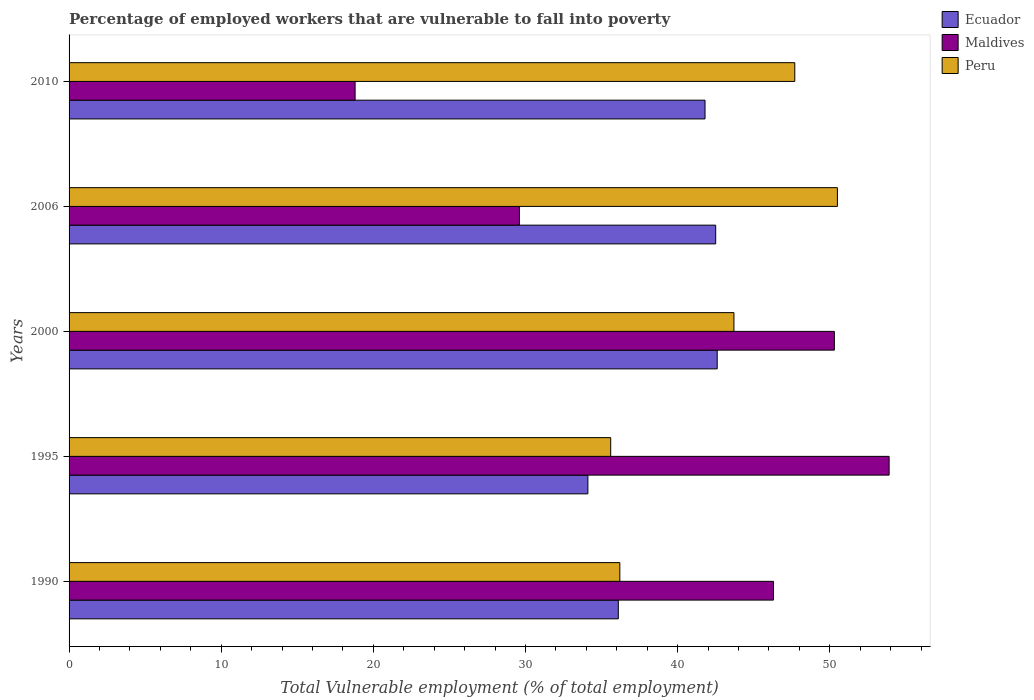How many different coloured bars are there?
Keep it short and to the point. 3. How many groups of bars are there?
Your answer should be compact. 5. Are the number of bars per tick equal to the number of legend labels?
Give a very brief answer. Yes. How many bars are there on the 5th tick from the top?
Keep it short and to the point. 3. What is the label of the 5th group of bars from the top?
Provide a short and direct response. 1990. In how many cases, is the number of bars for a given year not equal to the number of legend labels?
Provide a succinct answer. 0. What is the percentage of employed workers who are vulnerable to fall into poverty in Ecuador in 1995?
Make the answer very short. 34.1. Across all years, what is the maximum percentage of employed workers who are vulnerable to fall into poverty in Ecuador?
Make the answer very short. 42.6. Across all years, what is the minimum percentage of employed workers who are vulnerable to fall into poverty in Peru?
Your answer should be compact. 35.6. In which year was the percentage of employed workers who are vulnerable to fall into poverty in Ecuador maximum?
Provide a short and direct response. 2000. What is the total percentage of employed workers who are vulnerable to fall into poverty in Maldives in the graph?
Give a very brief answer. 198.9. What is the difference between the percentage of employed workers who are vulnerable to fall into poverty in Maldives in 2000 and that in 2010?
Ensure brevity in your answer.  31.5. What is the difference between the percentage of employed workers who are vulnerable to fall into poverty in Ecuador in 2000 and the percentage of employed workers who are vulnerable to fall into poverty in Maldives in 1995?
Provide a short and direct response. -11.3. What is the average percentage of employed workers who are vulnerable to fall into poverty in Peru per year?
Offer a terse response. 42.74. In the year 2006, what is the difference between the percentage of employed workers who are vulnerable to fall into poverty in Maldives and percentage of employed workers who are vulnerable to fall into poverty in Ecuador?
Your answer should be very brief. -12.9. What is the ratio of the percentage of employed workers who are vulnerable to fall into poverty in Maldives in 2000 to that in 2010?
Make the answer very short. 2.68. Is the percentage of employed workers who are vulnerable to fall into poverty in Peru in 1995 less than that in 2010?
Make the answer very short. Yes. What is the difference between the highest and the second highest percentage of employed workers who are vulnerable to fall into poverty in Maldives?
Your response must be concise. 3.6. What is the difference between the highest and the lowest percentage of employed workers who are vulnerable to fall into poverty in Peru?
Provide a short and direct response. 14.9. In how many years, is the percentage of employed workers who are vulnerable to fall into poverty in Ecuador greater than the average percentage of employed workers who are vulnerable to fall into poverty in Ecuador taken over all years?
Your response must be concise. 3. Is the sum of the percentage of employed workers who are vulnerable to fall into poverty in Ecuador in 2006 and 2010 greater than the maximum percentage of employed workers who are vulnerable to fall into poverty in Peru across all years?
Offer a very short reply. Yes. What does the 3rd bar from the top in 2006 represents?
Give a very brief answer. Ecuador. What does the 3rd bar from the bottom in 1995 represents?
Keep it short and to the point. Peru. How many years are there in the graph?
Your answer should be compact. 5. What is the difference between two consecutive major ticks on the X-axis?
Your answer should be compact. 10. Are the values on the major ticks of X-axis written in scientific E-notation?
Give a very brief answer. No. Does the graph contain any zero values?
Your answer should be compact. No. Does the graph contain grids?
Provide a short and direct response. No. Where does the legend appear in the graph?
Your answer should be very brief. Top right. How many legend labels are there?
Provide a succinct answer. 3. What is the title of the graph?
Your answer should be very brief. Percentage of employed workers that are vulnerable to fall into poverty. Does "Europe(developing only)" appear as one of the legend labels in the graph?
Ensure brevity in your answer.  No. What is the label or title of the X-axis?
Ensure brevity in your answer.  Total Vulnerable employment (% of total employment). What is the Total Vulnerable employment (% of total employment) of Ecuador in 1990?
Give a very brief answer. 36.1. What is the Total Vulnerable employment (% of total employment) of Maldives in 1990?
Your answer should be compact. 46.3. What is the Total Vulnerable employment (% of total employment) of Peru in 1990?
Provide a short and direct response. 36.2. What is the Total Vulnerable employment (% of total employment) of Ecuador in 1995?
Offer a terse response. 34.1. What is the Total Vulnerable employment (% of total employment) in Maldives in 1995?
Ensure brevity in your answer.  53.9. What is the Total Vulnerable employment (% of total employment) of Peru in 1995?
Ensure brevity in your answer.  35.6. What is the Total Vulnerable employment (% of total employment) in Ecuador in 2000?
Ensure brevity in your answer.  42.6. What is the Total Vulnerable employment (% of total employment) in Maldives in 2000?
Ensure brevity in your answer.  50.3. What is the Total Vulnerable employment (% of total employment) of Peru in 2000?
Offer a very short reply. 43.7. What is the Total Vulnerable employment (% of total employment) in Ecuador in 2006?
Keep it short and to the point. 42.5. What is the Total Vulnerable employment (% of total employment) of Maldives in 2006?
Your response must be concise. 29.6. What is the Total Vulnerable employment (% of total employment) of Peru in 2006?
Ensure brevity in your answer.  50.5. What is the Total Vulnerable employment (% of total employment) of Ecuador in 2010?
Your answer should be compact. 41.8. What is the Total Vulnerable employment (% of total employment) in Maldives in 2010?
Give a very brief answer. 18.8. What is the Total Vulnerable employment (% of total employment) of Peru in 2010?
Make the answer very short. 47.7. Across all years, what is the maximum Total Vulnerable employment (% of total employment) of Ecuador?
Your answer should be very brief. 42.6. Across all years, what is the maximum Total Vulnerable employment (% of total employment) of Maldives?
Your answer should be very brief. 53.9. Across all years, what is the maximum Total Vulnerable employment (% of total employment) of Peru?
Offer a terse response. 50.5. Across all years, what is the minimum Total Vulnerable employment (% of total employment) of Ecuador?
Your answer should be very brief. 34.1. Across all years, what is the minimum Total Vulnerable employment (% of total employment) of Maldives?
Offer a very short reply. 18.8. Across all years, what is the minimum Total Vulnerable employment (% of total employment) in Peru?
Offer a terse response. 35.6. What is the total Total Vulnerable employment (% of total employment) of Ecuador in the graph?
Offer a very short reply. 197.1. What is the total Total Vulnerable employment (% of total employment) in Maldives in the graph?
Provide a short and direct response. 198.9. What is the total Total Vulnerable employment (% of total employment) in Peru in the graph?
Offer a terse response. 213.7. What is the difference between the Total Vulnerable employment (% of total employment) in Ecuador in 1990 and that in 1995?
Your answer should be very brief. 2. What is the difference between the Total Vulnerable employment (% of total employment) of Maldives in 1990 and that in 1995?
Your response must be concise. -7.6. What is the difference between the Total Vulnerable employment (% of total employment) of Ecuador in 1990 and that in 2000?
Your response must be concise. -6.5. What is the difference between the Total Vulnerable employment (% of total employment) of Maldives in 1990 and that in 2000?
Your answer should be compact. -4. What is the difference between the Total Vulnerable employment (% of total employment) of Peru in 1990 and that in 2006?
Your answer should be compact. -14.3. What is the difference between the Total Vulnerable employment (% of total employment) in Maldives in 1990 and that in 2010?
Provide a succinct answer. 27.5. What is the difference between the Total Vulnerable employment (% of total employment) of Ecuador in 1995 and that in 2000?
Offer a very short reply. -8.5. What is the difference between the Total Vulnerable employment (% of total employment) of Maldives in 1995 and that in 2000?
Make the answer very short. 3.6. What is the difference between the Total Vulnerable employment (% of total employment) in Maldives in 1995 and that in 2006?
Your answer should be compact. 24.3. What is the difference between the Total Vulnerable employment (% of total employment) of Peru in 1995 and that in 2006?
Give a very brief answer. -14.9. What is the difference between the Total Vulnerable employment (% of total employment) of Ecuador in 1995 and that in 2010?
Your answer should be compact. -7.7. What is the difference between the Total Vulnerable employment (% of total employment) in Maldives in 1995 and that in 2010?
Your answer should be very brief. 35.1. What is the difference between the Total Vulnerable employment (% of total employment) of Maldives in 2000 and that in 2006?
Provide a succinct answer. 20.7. What is the difference between the Total Vulnerable employment (% of total employment) in Peru in 2000 and that in 2006?
Provide a short and direct response. -6.8. What is the difference between the Total Vulnerable employment (% of total employment) in Maldives in 2000 and that in 2010?
Your answer should be very brief. 31.5. What is the difference between the Total Vulnerable employment (% of total employment) in Maldives in 2006 and that in 2010?
Your response must be concise. 10.8. What is the difference between the Total Vulnerable employment (% of total employment) in Ecuador in 1990 and the Total Vulnerable employment (% of total employment) in Maldives in 1995?
Offer a terse response. -17.8. What is the difference between the Total Vulnerable employment (% of total employment) in Ecuador in 1990 and the Total Vulnerable employment (% of total employment) in Peru in 1995?
Offer a terse response. 0.5. What is the difference between the Total Vulnerable employment (% of total employment) in Maldives in 1990 and the Total Vulnerable employment (% of total employment) in Peru in 1995?
Ensure brevity in your answer.  10.7. What is the difference between the Total Vulnerable employment (% of total employment) of Ecuador in 1990 and the Total Vulnerable employment (% of total employment) of Maldives in 2000?
Offer a terse response. -14.2. What is the difference between the Total Vulnerable employment (% of total employment) of Maldives in 1990 and the Total Vulnerable employment (% of total employment) of Peru in 2000?
Ensure brevity in your answer.  2.6. What is the difference between the Total Vulnerable employment (% of total employment) of Ecuador in 1990 and the Total Vulnerable employment (% of total employment) of Peru in 2006?
Give a very brief answer. -14.4. What is the difference between the Total Vulnerable employment (% of total employment) in Maldives in 1990 and the Total Vulnerable employment (% of total employment) in Peru in 2006?
Your response must be concise. -4.2. What is the difference between the Total Vulnerable employment (% of total employment) in Ecuador in 1990 and the Total Vulnerable employment (% of total employment) in Maldives in 2010?
Keep it short and to the point. 17.3. What is the difference between the Total Vulnerable employment (% of total employment) in Ecuador in 1990 and the Total Vulnerable employment (% of total employment) in Peru in 2010?
Give a very brief answer. -11.6. What is the difference between the Total Vulnerable employment (% of total employment) in Ecuador in 1995 and the Total Vulnerable employment (% of total employment) in Maldives in 2000?
Your answer should be very brief. -16.2. What is the difference between the Total Vulnerable employment (% of total employment) in Ecuador in 1995 and the Total Vulnerable employment (% of total employment) in Peru in 2000?
Your answer should be compact. -9.6. What is the difference between the Total Vulnerable employment (% of total employment) in Maldives in 1995 and the Total Vulnerable employment (% of total employment) in Peru in 2000?
Your answer should be compact. 10.2. What is the difference between the Total Vulnerable employment (% of total employment) of Ecuador in 1995 and the Total Vulnerable employment (% of total employment) of Maldives in 2006?
Provide a short and direct response. 4.5. What is the difference between the Total Vulnerable employment (% of total employment) of Ecuador in 1995 and the Total Vulnerable employment (% of total employment) of Peru in 2006?
Make the answer very short. -16.4. What is the difference between the Total Vulnerable employment (% of total employment) in Maldives in 1995 and the Total Vulnerable employment (% of total employment) in Peru in 2006?
Your answer should be compact. 3.4. What is the difference between the Total Vulnerable employment (% of total employment) of Ecuador in 2000 and the Total Vulnerable employment (% of total employment) of Maldives in 2006?
Your answer should be very brief. 13. What is the difference between the Total Vulnerable employment (% of total employment) of Ecuador in 2000 and the Total Vulnerable employment (% of total employment) of Peru in 2006?
Offer a terse response. -7.9. What is the difference between the Total Vulnerable employment (% of total employment) in Maldives in 2000 and the Total Vulnerable employment (% of total employment) in Peru in 2006?
Make the answer very short. -0.2. What is the difference between the Total Vulnerable employment (% of total employment) of Ecuador in 2000 and the Total Vulnerable employment (% of total employment) of Maldives in 2010?
Make the answer very short. 23.8. What is the difference between the Total Vulnerable employment (% of total employment) of Ecuador in 2006 and the Total Vulnerable employment (% of total employment) of Maldives in 2010?
Your answer should be very brief. 23.7. What is the difference between the Total Vulnerable employment (% of total employment) of Ecuador in 2006 and the Total Vulnerable employment (% of total employment) of Peru in 2010?
Offer a very short reply. -5.2. What is the difference between the Total Vulnerable employment (% of total employment) of Maldives in 2006 and the Total Vulnerable employment (% of total employment) of Peru in 2010?
Give a very brief answer. -18.1. What is the average Total Vulnerable employment (% of total employment) in Ecuador per year?
Your answer should be very brief. 39.42. What is the average Total Vulnerable employment (% of total employment) in Maldives per year?
Your answer should be very brief. 39.78. What is the average Total Vulnerable employment (% of total employment) in Peru per year?
Provide a succinct answer. 42.74. In the year 1990, what is the difference between the Total Vulnerable employment (% of total employment) in Ecuador and Total Vulnerable employment (% of total employment) in Peru?
Provide a short and direct response. -0.1. In the year 1990, what is the difference between the Total Vulnerable employment (% of total employment) of Maldives and Total Vulnerable employment (% of total employment) of Peru?
Your response must be concise. 10.1. In the year 1995, what is the difference between the Total Vulnerable employment (% of total employment) of Ecuador and Total Vulnerable employment (% of total employment) of Maldives?
Give a very brief answer. -19.8. In the year 1995, what is the difference between the Total Vulnerable employment (% of total employment) in Ecuador and Total Vulnerable employment (% of total employment) in Peru?
Provide a succinct answer. -1.5. In the year 1995, what is the difference between the Total Vulnerable employment (% of total employment) in Maldives and Total Vulnerable employment (% of total employment) in Peru?
Your answer should be compact. 18.3. In the year 2000, what is the difference between the Total Vulnerable employment (% of total employment) of Ecuador and Total Vulnerable employment (% of total employment) of Peru?
Keep it short and to the point. -1.1. In the year 2000, what is the difference between the Total Vulnerable employment (% of total employment) in Maldives and Total Vulnerable employment (% of total employment) in Peru?
Offer a terse response. 6.6. In the year 2006, what is the difference between the Total Vulnerable employment (% of total employment) in Ecuador and Total Vulnerable employment (% of total employment) in Maldives?
Offer a very short reply. 12.9. In the year 2006, what is the difference between the Total Vulnerable employment (% of total employment) in Maldives and Total Vulnerable employment (% of total employment) in Peru?
Your answer should be very brief. -20.9. In the year 2010, what is the difference between the Total Vulnerable employment (% of total employment) of Ecuador and Total Vulnerable employment (% of total employment) of Maldives?
Your answer should be very brief. 23. In the year 2010, what is the difference between the Total Vulnerable employment (% of total employment) in Maldives and Total Vulnerable employment (% of total employment) in Peru?
Give a very brief answer. -28.9. What is the ratio of the Total Vulnerable employment (% of total employment) in Ecuador in 1990 to that in 1995?
Your answer should be very brief. 1.06. What is the ratio of the Total Vulnerable employment (% of total employment) in Maldives in 1990 to that in 1995?
Ensure brevity in your answer.  0.86. What is the ratio of the Total Vulnerable employment (% of total employment) of Peru in 1990 to that in 1995?
Make the answer very short. 1.02. What is the ratio of the Total Vulnerable employment (% of total employment) in Ecuador in 1990 to that in 2000?
Offer a very short reply. 0.85. What is the ratio of the Total Vulnerable employment (% of total employment) of Maldives in 1990 to that in 2000?
Your answer should be compact. 0.92. What is the ratio of the Total Vulnerable employment (% of total employment) of Peru in 1990 to that in 2000?
Give a very brief answer. 0.83. What is the ratio of the Total Vulnerable employment (% of total employment) of Ecuador in 1990 to that in 2006?
Provide a succinct answer. 0.85. What is the ratio of the Total Vulnerable employment (% of total employment) of Maldives in 1990 to that in 2006?
Offer a terse response. 1.56. What is the ratio of the Total Vulnerable employment (% of total employment) of Peru in 1990 to that in 2006?
Provide a short and direct response. 0.72. What is the ratio of the Total Vulnerable employment (% of total employment) of Ecuador in 1990 to that in 2010?
Provide a succinct answer. 0.86. What is the ratio of the Total Vulnerable employment (% of total employment) of Maldives in 1990 to that in 2010?
Make the answer very short. 2.46. What is the ratio of the Total Vulnerable employment (% of total employment) in Peru in 1990 to that in 2010?
Keep it short and to the point. 0.76. What is the ratio of the Total Vulnerable employment (% of total employment) in Ecuador in 1995 to that in 2000?
Offer a terse response. 0.8. What is the ratio of the Total Vulnerable employment (% of total employment) in Maldives in 1995 to that in 2000?
Provide a succinct answer. 1.07. What is the ratio of the Total Vulnerable employment (% of total employment) in Peru in 1995 to that in 2000?
Provide a succinct answer. 0.81. What is the ratio of the Total Vulnerable employment (% of total employment) of Ecuador in 1995 to that in 2006?
Provide a short and direct response. 0.8. What is the ratio of the Total Vulnerable employment (% of total employment) in Maldives in 1995 to that in 2006?
Make the answer very short. 1.82. What is the ratio of the Total Vulnerable employment (% of total employment) in Peru in 1995 to that in 2006?
Keep it short and to the point. 0.7. What is the ratio of the Total Vulnerable employment (% of total employment) of Ecuador in 1995 to that in 2010?
Make the answer very short. 0.82. What is the ratio of the Total Vulnerable employment (% of total employment) of Maldives in 1995 to that in 2010?
Provide a short and direct response. 2.87. What is the ratio of the Total Vulnerable employment (% of total employment) in Peru in 1995 to that in 2010?
Give a very brief answer. 0.75. What is the ratio of the Total Vulnerable employment (% of total employment) of Ecuador in 2000 to that in 2006?
Ensure brevity in your answer.  1. What is the ratio of the Total Vulnerable employment (% of total employment) of Maldives in 2000 to that in 2006?
Keep it short and to the point. 1.7. What is the ratio of the Total Vulnerable employment (% of total employment) in Peru in 2000 to that in 2006?
Offer a very short reply. 0.87. What is the ratio of the Total Vulnerable employment (% of total employment) of Ecuador in 2000 to that in 2010?
Your response must be concise. 1.02. What is the ratio of the Total Vulnerable employment (% of total employment) of Maldives in 2000 to that in 2010?
Your response must be concise. 2.68. What is the ratio of the Total Vulnerable employment (% of total employment) of Peru in 2000 to that in 2010?
Make the answer very short. 0.92. What is the ratio of the Total Vulnerable employment (% of total employment) of Ecuador in 2006 to that in 2010?
Offer a very short reply. 1.02. What is the ratio of the Total Vulnerable employment (% of total employment) in Maldives in 2006 to that in 2010?
Your answer should be compact. 1.57. What is the ratio of the Total Vulnerable employment (% of total employment) of Peru in 2006 to that in 2010?
Keep it short and to the point. 1.06. What is the difference between the highest and the second highest Total Vulnerable employment (% of total employment) of Ecuador?
Give a very brief answer. 0.1. What is the difference between the highest and the lowest Total Vulnerable employment (% of total employment) in Ecuador?
Give a very brief answer. 8.5. What is the difference between the highest and the lowest Total Vulnerable employment (% of total employment) of Maldives?
Provide a succinct answer. 35.1. What is the difference between the highest and the lowest Total Vulnerable employment (% of total employment) in Peru?
Your answer should be very brief. 14.9. 